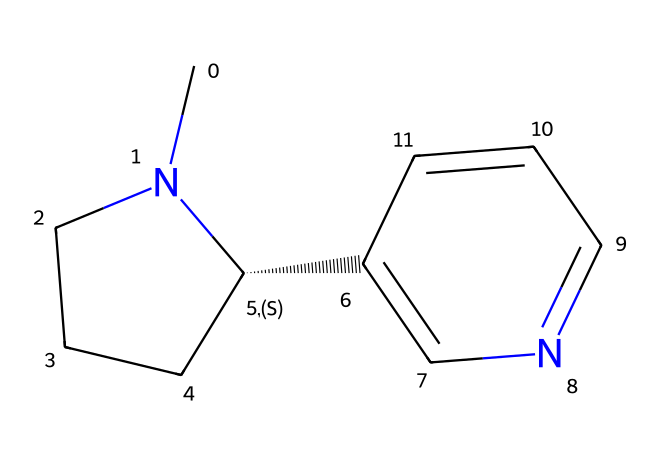What is the primary functional group present in the structure? The structure contains a nitrogen atom in a ring formation, which is characteristic of amines, making it an amine functional group.
Answer: amine How many carbon atoms are in this nicotine structure? By examining the SMILES representation, we count a total of 10 carbon atoms that contribute to the molecular structure.
Answer: 10 Does this chemical structure include any rings? The structure shows cyclic arrangements of atoms, indicating there are rings present in the molecule.
Answer: yes What type of chemical is nicotine classified as? From its structure, which includes nitrogen in a heterocyclic ring, nicotine is classified as an alkaloid, a specific type of toxic chemical.
Answer: alkaloid What role do nitrogen atoms play in the toxicity of nicotine? Nitrogen atoms facilitate the formation of basic properties in nicotine, which contribute to its toxic effects by interacting with neurotransmitter receptors in the brain.
Answer: toxicity How many double bonds are present in the nicotine structure? Analyzing the structure reveals there is one double bond present, which is accounted for in the fused ring system of the molecule.
Answer: 1 What element other than carbon and hydrogen is predominantly featured in the nicotine structure? The nitrogen atom is the other significant element present in the nicotine structure, contributing to its biological activity and toxicity.
Answer: nitrogen 